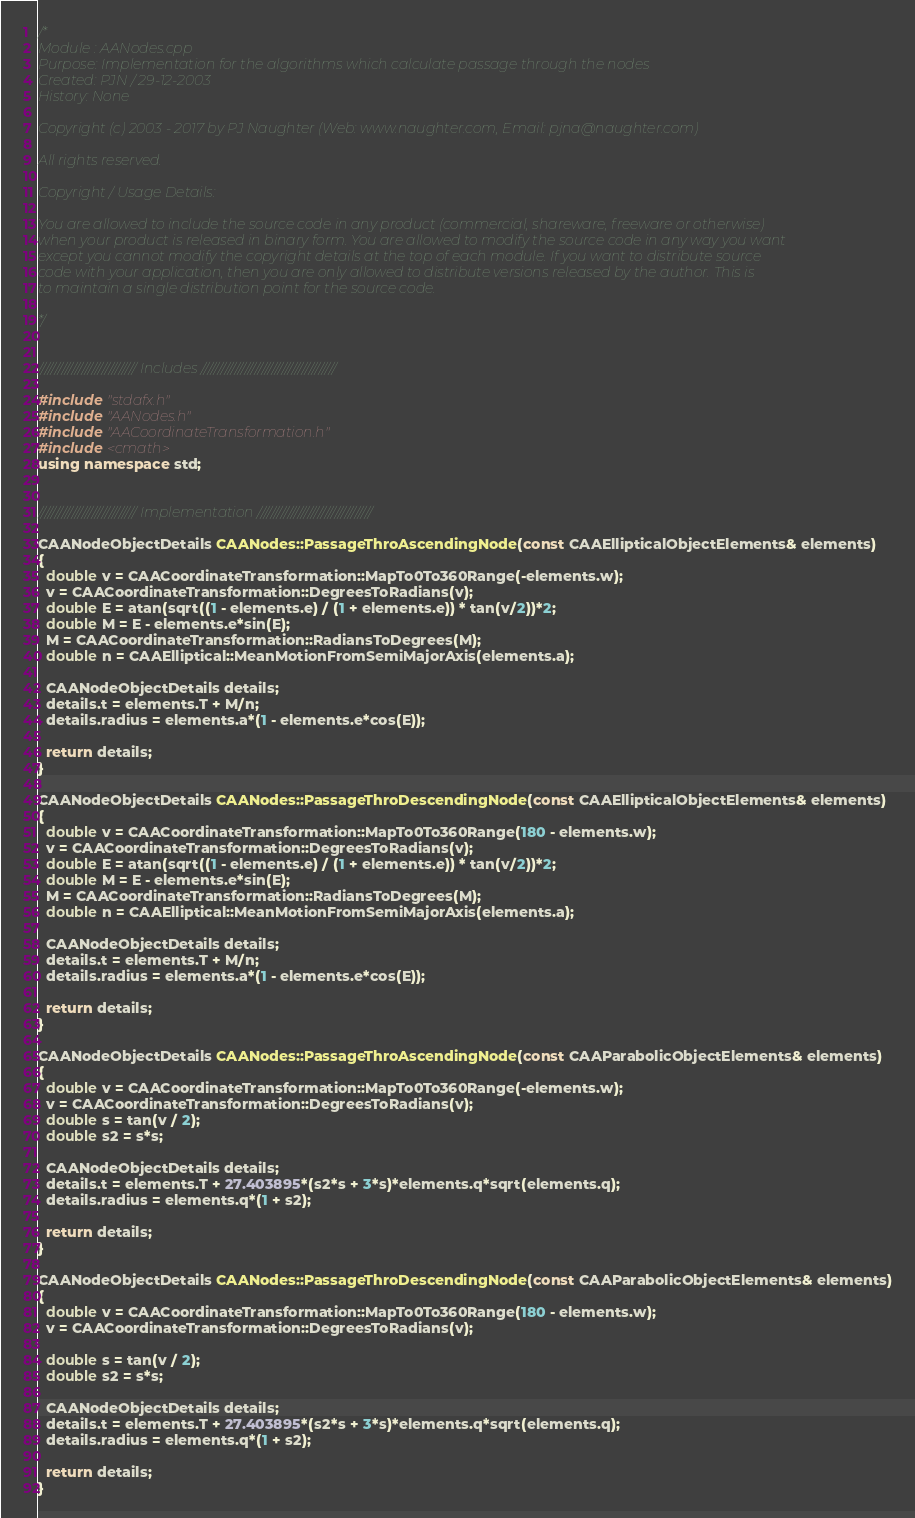<code> <loc_0><loc_0><loc_500><loc_500><_C++_>/*
Module : AANodes.cpp
Purpose: Implementation for the algorithms which calculate passage through the nodes
Created: PJN / 29-12-2003
History: None

Copyright (c) 2003 - 2017 by PJ Naughter (Web: www.naughter.com, Email: pjna@naughter.com)

All rights reserved.

Copyright / Usage Details:

You are allowed to include the source code in any product (commercial, shareware, freeware or otherwise) 
when your product is released in binary form. You are allowed to modify the source code in any way you want 
except you cannot modify the copyright details at the top of each module. If you want to distribute source 
code with your application, then you are only allowed to distribute versions released by the author. This is 
to maintain a single distribution point for the source code. 

*/


///////////////////////////// Includes ////////////////////////////////////////

#include "stdafx.h"
#include "AANodes.h"
#include "AACoordinateTransformation.h"
#include <cmath>
using namespace std;


///////////////////////////// Implementation //////////////////////////////////

CAANodeObjectDetails CAANodes::PassageThroAscendingNode(const CAAEllipticalObjectElements& elements)
{
  double v = CAACoordinateTransformation::MapTo0To360Range(-elements.w);
  v = CAACoordinateTransformation::DegreesToRadians(v);
  double E = atan(sqrt((1 - elements.e) / (1 + elements.e)) * tan(v/2))*2;
  double M = E - elements.e*sin(E);
  M = CAACoordinateTransformation::RadiansToDegrees(M);
  double n = CAAElliptical::MeanMotionFromSemiMajorAxis(elements.a);

  CAANodeObjectDetails details;
  details.t = elements.T + M/n;
  details.radius = elements.a*(1 - elements.e*cos(E));

  return details;
}

CAANodeObjectDetails CAANodes::PassageThroDescendingNode(const CAAEllipticalObjectElements& elements)
{
  double v = CAACoordinateTransformation::MapTo0To360Range(180 - elements.w);
  v = CAACoordinateTransformation::DegreesToRadians(v);
  double E = atan(sqrt((1 - elements.e) / (1 + elements.e)) * tan(v/2))*2;
  double M = E - elements.e*sin(E);
  M = CAACoordinateTransformation::RadiansToDegrees(M);
  double n = CAAElliptical::MeanMotionFromSemiMajorAxis(elements.a);

  CAANodeObjectDetails details;
  details.t = elements.T + M/n;
  details.radius = elements.a*(1 - elements.e*cos(E));

  return details;
}

CAANodeObjectDetails CAANodes::PassageThroAscendingNode(const CAAParabolicObjectElements& elements)
{
  double v = CAACoordinateTransformation::MapTo0To360Range(-elements.w);
  v = CAACoordinateTransformation::DegreesToRadians(v);
  double s = tan(v / 2);
  double s2 = s*s;

  CAANodeObjectDetails details;
  details.t = elements.T + 27.403895*(s2*s + 3*s)*elements.q*sqrt(elements.q);
  details.radius = elements.q*(1 + s2);

  return details;
}

CAANodeObjectDetails CAANodes::PassageThroDescendingNode(const CAAParabolicObjectElements& elements)
{
  double v = CAACoordinateTransformation::MapTo0To360Range(180 - elements.w);
  v = CAACoordinateTransformation::DegreesToRadians(v);

  double s = tan(v / 2);
  double s2 = s*s;

  CAANodeObjectDetails details;
  details.t = elements.T + 27.403895*(s2*s + 3*s)*elements.q*sqrt(elements.q);
  details.radius = elements.q*(1 + s2);

  return details;
}
</code> 